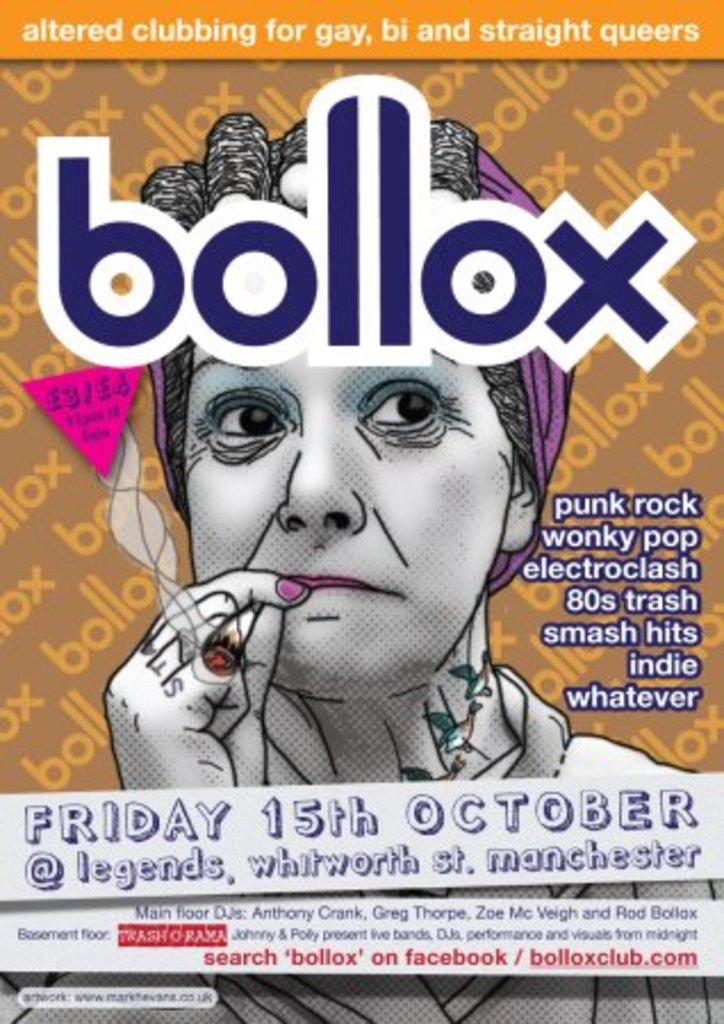<image>
Present a compact description of the photo's key features. A flyer for a club in Manchester called Bollox. 